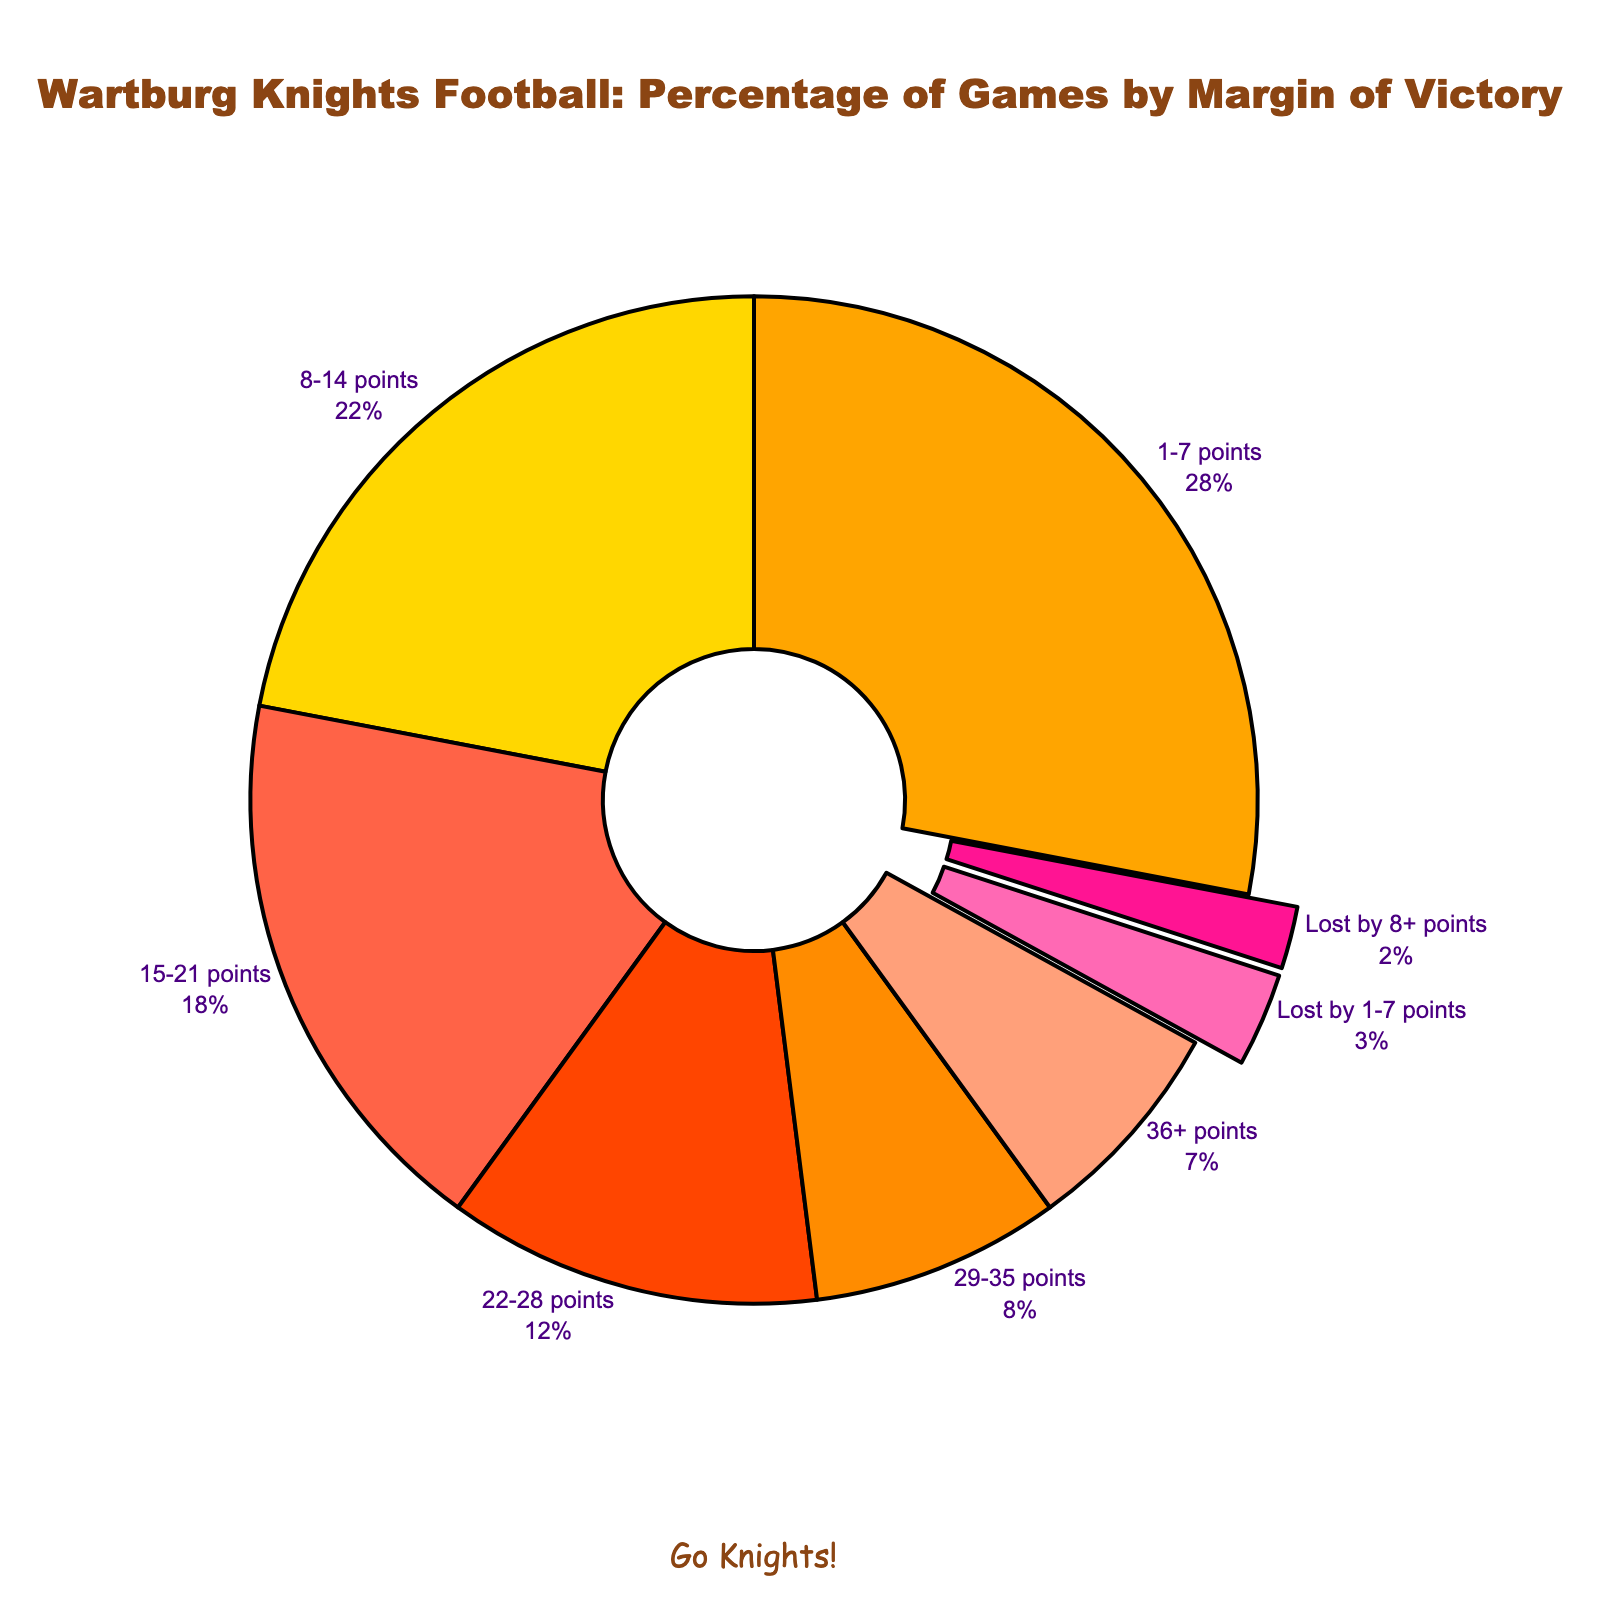Which margin of victory category has the highest percentage of wins? The segment with the highest percentage of wins is the largest slice on the pie chart.
Answer: 1-7 points What is the combined percentage of games won by 8-21 points? Add the percentage of games won by 8-14 points (22%) and 15-21 points (18%).
Answer: 40% How many different categories are there where the Knights lost? Count the distinctly labeled segments that indicate losses. There are "Lost by 1-7 points" and "Lost by 8+ points".
Answer: 2 Which margin of victory category is represented by the smallest slice? The smallest slice on the pie chart visually represents the category with the smallest percentage, which is "Lost by 8+ points".
Answer: Lost by 8+ points What percentage of games were won by more than 28 points? Add the percentages for margin categories "29-35 points" (8%) and "36+ points" (7%)
Answer: 15% Is the percentage of games won within 22-28 points greater than the percentage of games won within 8-14 points? Compare the two percentages, 22% for 8-14 points and 12% for 22-28 points.
Answer: No Which color represents the games lost by 1-7 points? Identify the color associated with the "Lost by 1-7 points" segment. It's distinctively pulled out, in a pinkish hue.
Answer: Pink What is the difference in percentage between games won by 1-7 points and games won by 29-35 points? Subtract the percentage of the 29-35 points category (8%) from the 1-7 points category (28%).
Answer: 20% What feature differentiates the segments where the Knights lost from the rest? The segments representing losses are visually distinguished by being slightly pulled away from the pie chart.
Answer: Pulled out segments 